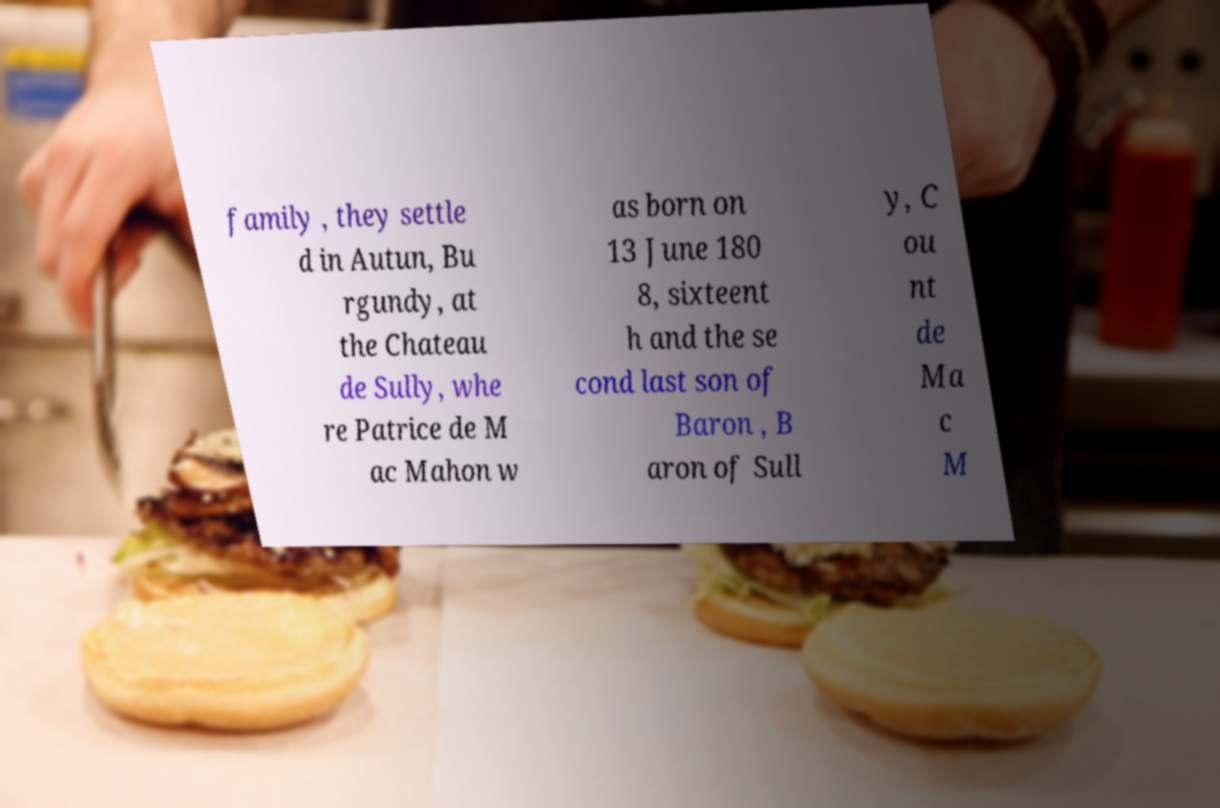Please read and relay the text visible in this image. What does it say? family , they settle d in Autun, Bu rgundy, at the Chateau de Sully, whe re Patrice de M ac Mahon w as born on 13 June 180 8, sixteent h and the se cond last son of Baron , B aron of Sull y, C ou nt de Ma c M 